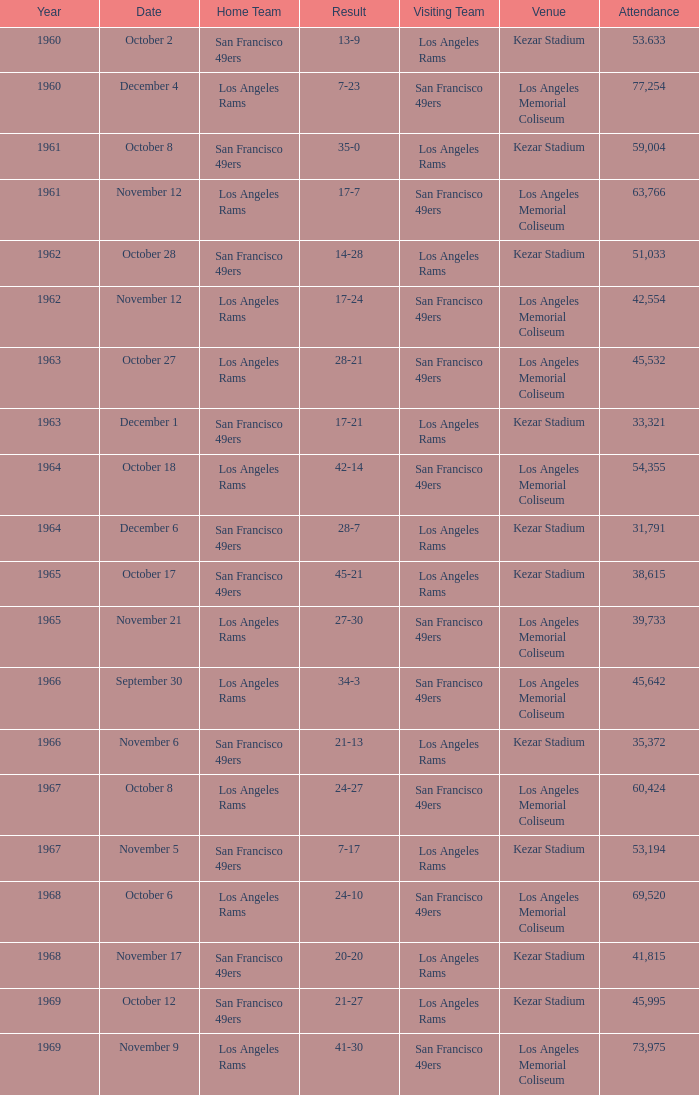What was the overall attendance for an outcome of 7-23 prior to 1960? None. Write the full table. {'header': ['Year', 'Date', 'Home Team', 'Result', 'Visiting Team', 'Venue', 'Attendance'], 'rows': [['1960', 'October 2', 'San Francisco 49ers', '13-9', 'Los Angeles Rams', 'Kezar Stadium', '53.633'], ['1960', 'December 4', 'Los Angeles Rams', '7-23', 'San Francisco 49ers', 'Los Angeles Memorial Coliseum', '77,254'], ['1961', 'October 8', 'San Francisco 49ers', '35-0', 'Los Angeles Rams', 'Kezar Stadium', '59,004'], ['1961', 'November 12', 'Los Angeles Rams', '17-7', 'San Francisco 49ers', 'Los Angeles Memorial Coliseum', '63,766'], ['1962', 'October 28', 'San Francisco 49ers', '14-28', 'Los Angeles Rams', 'Kezar Stadium', '51,033'], ['1962', 'November 12', 'Los Angeles Rams', '17-24', 'San Francisco 49ers', 'Los Angeles Memorial Coliseum', '42,554'], ['1963', 'October 27', 'Los Angeles Rams', '28-21', 'San Francisco 49ers', 'Los Angeles Memorial Coliseum', '45,532'], ['1963', 'December 1', 'San Francisco 49ers', '17-21', 'Los Angeles Rams', 'Kezar Stadium', '33,321'], ['1964', 'October 18', 'Los Angeles Rams', '42-14', 'San Francisco 49ers', 'Los Angeles Memorial Coliseum', '54,355'], ['1964', 'December 6', 'San Francisco 49ers', '28-7', 'Los Angeles Rams', 'Kezar Stadium', '31,791'], ['1965', 'October 17', 'San Francisco 49ers', '45-21', 'Los Angeles Rams', 'Kezar Stadium', '38,615'], ['1965', 'November 21', 'Los Angeles Rams', '27-30', 'San Francisco 49ers', 'Los Angeles Memorial Coliseum', '39,733'], ['1966', 'September 30', 'Los Angeles Rams', '34-3', 'San Francisco 49ers', 'Los Angeles Memorial Coliseum', '45,642'], ['1966', 'November 6', 'San Francisco 49ers', '21-13', 'Los Angeles Rams', 'Kezar Stadium', '35,372'], ['1967', 'October 8', 'Los Angeles Rams', '24-27', 'San Francisco 49ers', 'Los Angeles Memorial Coliseum', '60,424'], ['1967', 'November 5', 'San Francisco 49ers', '7-17', 'Los Angeles Rams', 'Kezar Stadium', '53,194'], ['1968', 'October 6', 'Los Angeles Rams', '24-10', 'San Francisco 49ers', 'Los Angeles Memorial Coliseum', '69,520'], ['1968', 'November 17', 'San Francisco 49ers', '20-20', 'Los Angeles Rams', 'Kezar Stadium', '41,815'], ['1969', 'October 12', 'San Francisco 49ers', '21-27', 'Los Angeles Rams', 'Kezar Stadium', '45,995'], ['1969', 'November 9', 'Los Angeles Rams', '41-30', 'San Francisco 49ers', 'Los Angeles Memorial Coliseum', '73,975']]} 